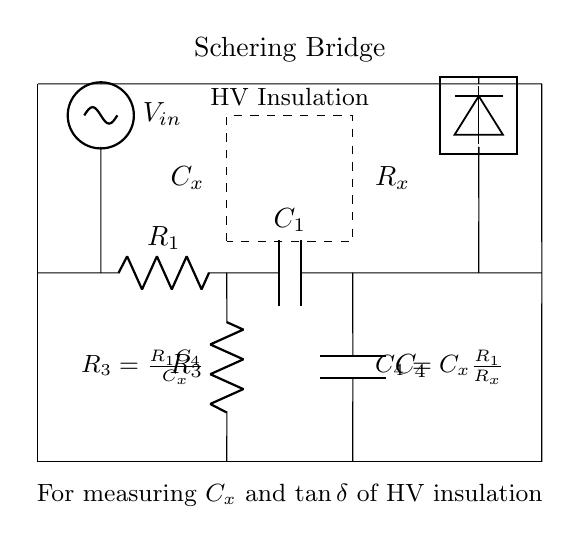What type of circuit is depicted in this diagram? The diagram represents a Schering Bridge circuit, which is specifically used for measuring capacitance and loss (dissipation factor) in high-voltage insulation.
Answer: Schering Bridge What component is represented by C1? In the diagram, C1 is labeled as a capacitor. It is part of the bridge circuit and is used to balance the circuit for measurements.
Answer: C1 What is the relationship between R3 and C4 in the circuit? R3 is equal to R1 multiplied by C4 divided by Cx, as indicated in the diagram's annotations. This reflects how the resistance and capacitance relate in the balancing condition of the bridge.
Answer: R3 = R1 * C4 / Cx What does R_x represent in the schematic? R_x is the unknown resistance associated with the high-voltage insulation, which the Schering Bridge aims to measure by comparing it with known values in the circuit.
Answer: R_x How many resistors are in this circuit? There are two resistors in this Schering Bridge circuit: R1 and R3. They play specific roles in balancing the bridge and facilitating measurements related to capacitance and dissipation factor.
Answer: 2 What does the voltage source represent in this circuit? The voltage source, labeled as V_in, provides the input signal for the circuit. This enables the measurement of the response of the insulation material being tested, facilitating the determination of its properties.
Answer: V_in What does the detector measure in this Schering Bridge configuration? The detector measures the output signal that indicates the balance condition of the bridge, which correlates with the capacitance and dissipation factor of the insulation material under test.
Answer: Detector 